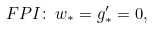Convert formula to latex. <formula><loc_0><loc_0><loc_500><loc_500>F P I \colon \, w _ { * } = g _ { * } ^ { \prime } = 0 ,</formula> 